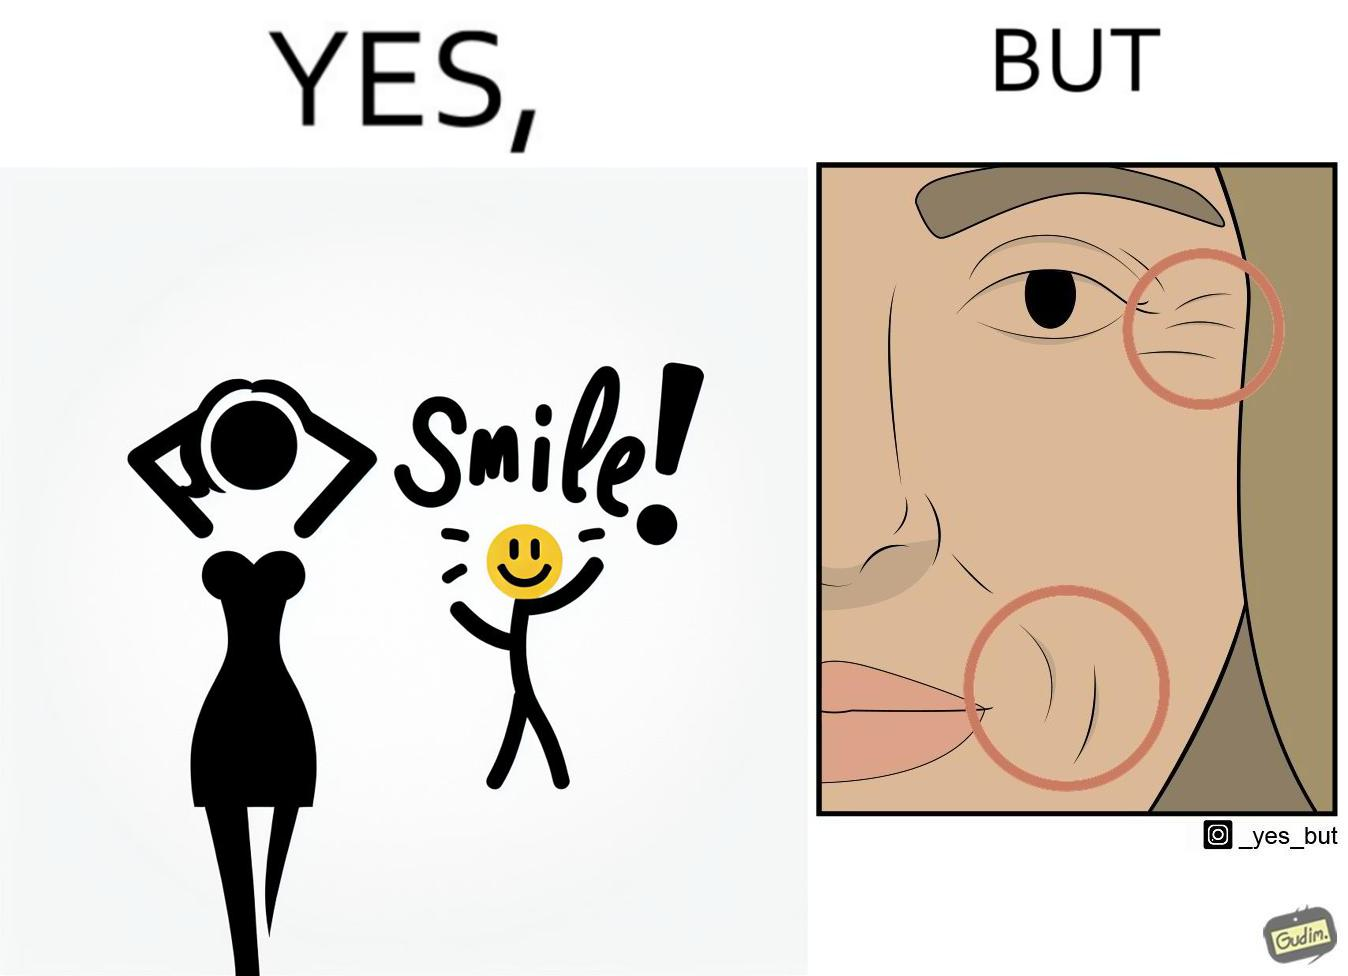What makes this image funny or satirical? The image is ironical because while it suggests people to smile it also shows the wrinkles that can be caused around lips and eyes because of smiling 